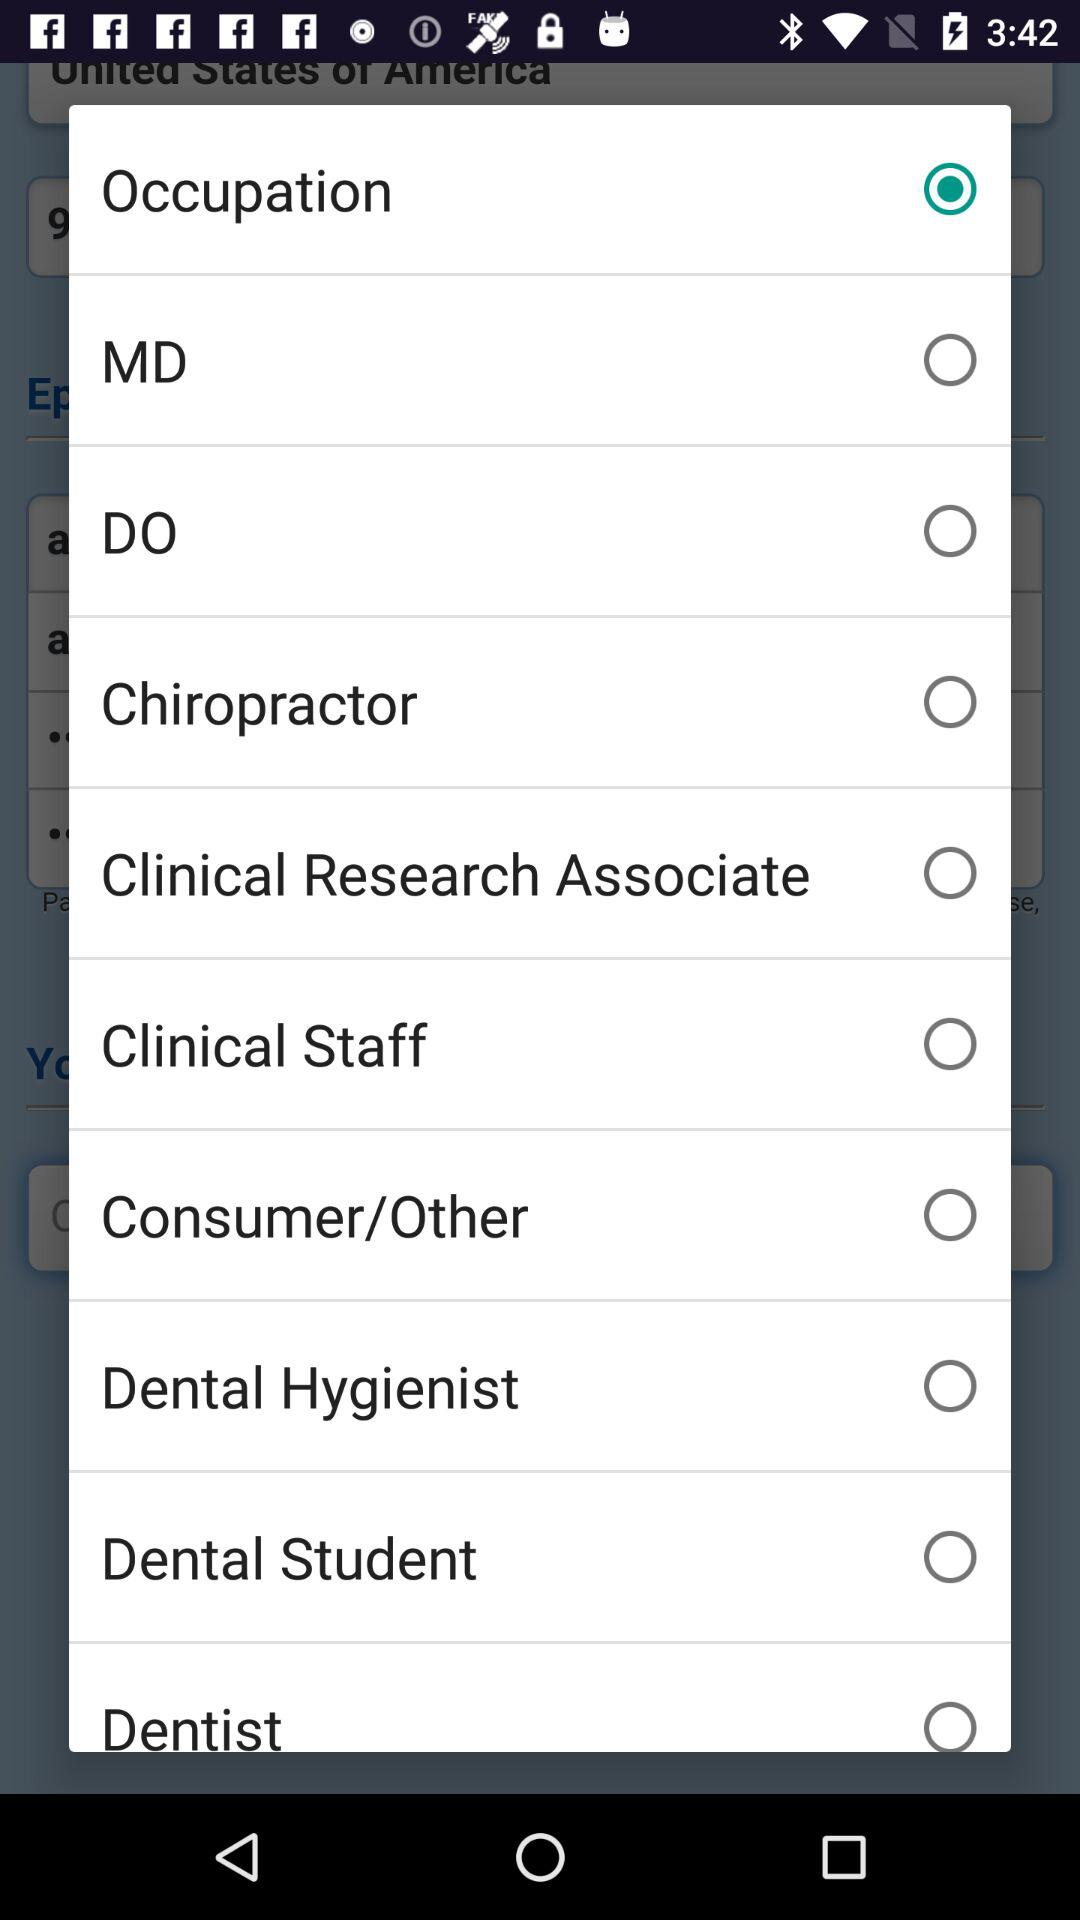What's the selected option? The selected option is "Occupation". 